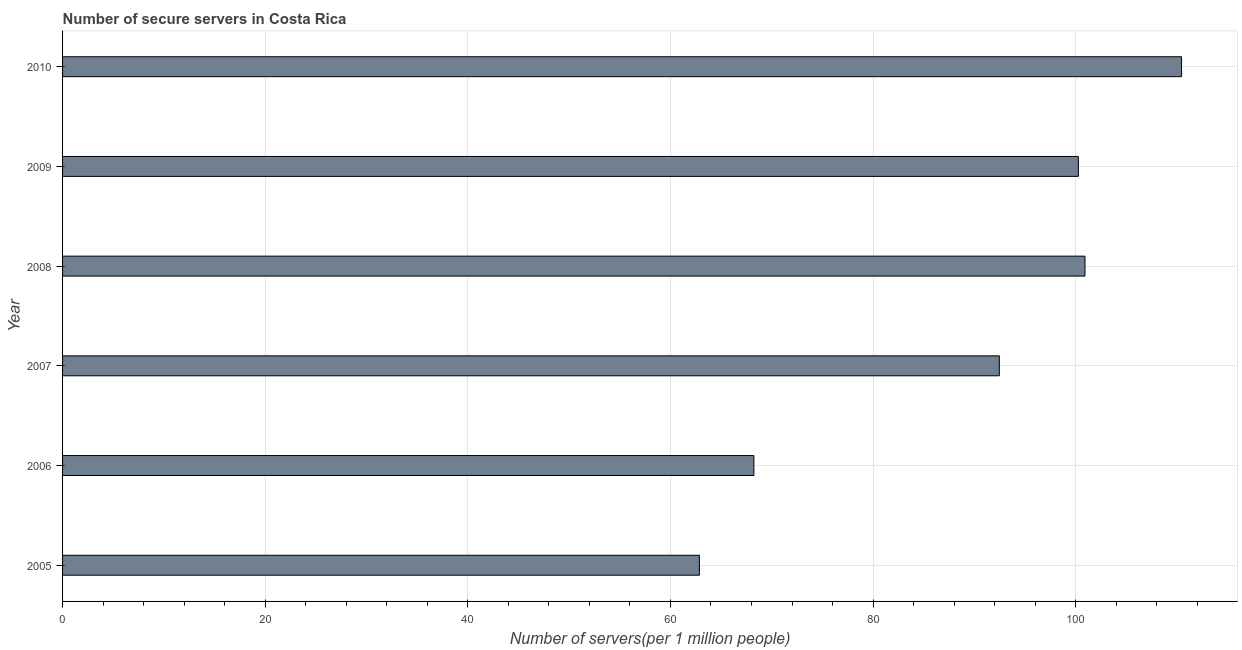Does the graph contain any zero values?
Your answer should be compact. No. Does the graph contain grids?
Your answer should be compact. Yes. What is the title of the graph?
Offer a terse response. Number of secure servers in Costa Rica. What is the label or title of the X-axis?
Give a very brief answer. Number of servers(per 1 million people). What is the label or title of the Y-axis?
Your answer should be very brief. Year. What is the number of secure internet servers in 2010?
Provide a short and direct response. 110.44. Across all years, what is the maximum number of secure internet servers?
Provide a succinct answer. 110.44. Across all years, what is the minimum number of secure internet servers?
Make the answer very short. 62.86. In which year was the number of secure internet servers maximum?
Provide a succinct answer. 2010. What is the sum of the number of secure internet servers?
Offer a terse response. 535.17. What is the difference between the number of secure internet servers in 2007 and 2008?
Offer a very short reply. -8.45. What is the average number of secure internet servers per year?
Keep it short and to the point. 89.19. What is the median number of secure internet servers?
Your answer should be compact. 96.36. In how many years, is the number of secure internet servers greater than 64 ?
Your response must be concise. 5. What is the ratio of the number of secure internet servers in 2005 to that in 2007?
Make the answer very short. 0.68. Is the number of secure internet servers in 2008 less than that in 2010?
Make the answer very short. Yes. What is the difference between the highest and the second highest number of secure internet servers?
Your answer should be very brief. 9.53. What is the difference between the highest and the lowest number of secure internet servers?
Make the answer very short. 47.59. In how many years, is the number of secure internet servers greater than the average number of secure internet servers taken over all years?
Your response must be concise. 4. How many bars are there?
Your answer should be very brief. 6. Are all the bars in the graph horizontal?
Your response must be concise. Yes. How many years are there in the graph?
Give a very brief answer. 6. What is the Number of servers(per 1 million people) in 2005?
Keep it short and to the point. 62.86. What is the Number of servers(per 1 million people) in 2006?
Offer a very short reply. 68.23. What is the Number of servers(per 1 million people) of 2007?
Ensure brevity in your answer.  92.46. What is the Number of servers(per 1 million people) in 2008?
Keep it short and to the point. 100.91. What is the Number of servers(per 1 million people) of 2009?
Give a very brief answer. 100.26. What is the Number of servers(per 1 million people) in 2010?
Ensure brevity in your answer.  110.44. What is the difference between the Number of servers(per 1 million people) in 2005 and 2006?
Offer a terse response. -5.38. What is the difference between the Number of servers(per 1 million people) in 2005 and 2007?
Your answer should be compact. -29.6. What is the difference between the Number of servers(per 1 million people) in 2005 and 2008?
Make the answer very short. -38.06. What is the difference between the Number of servers(per 1 million people) in 2005 and 2009?
Provide a short and direct response. -37.41. What is the difference between the Number of servers(per 1 million people) in 2005 and 2010?
Give a very brief answer. -47.59. What is the difference between the Number of servers(per 1 million people) in 2006 and 2007?
Offer a very short reply. -24.23. What is the difference between the Number of servers(per 1 million people) in 2006 and 2008?
Provide a succinct answer. -32.68. What is the difference between the Number of servers(per 1 million people) in 2006 and 2009?
Make the answer very short. -32.03. What is the difference between the Number of servers(per 1 million people) in 2006 and 2010?
Give a very brief answer. -42.21. What is the difference between the Number of servers(per 1 million people) in 2007 and 2008?
Offer a terse response. -8.45. What is the difference between the Number of servers(per 1 million people) in 2007 and 2009?
Keep it short and to the point. -7.8. What is the difference between the Number of servers(per 1 million people) in 2007 and 2010?
Keep it short and to the point. -17.98. What is the difference between the Number of servers(per 1 million people) in 2008 and 2009?
Your answer should be very brief. 0.65. What is the difference between the Number of servers(per 1 million people) in 2008 and 2010?
Offer a very short reply. -9.53. What is the difference between the Number of servers(per 1 million people) in 2009 and 2010?
Give a very brief answer. -10.18. What is the ratio of the Number of servers(per 1 million people) in 2005 to that in 2006?
Your answer should be very brief. 0.92. What is the ratio of the Number of servers(per 1 million people) in 2005 to that in 2007?
Offer a very short reply. 0.68. What is the ratio of the Number of servers(per 1 million people) in 2005 to that in 2008?
Make the answer very short. 0.62. What is the ratio of the Number of servers(per 1 million people) in 2005 to that in 2009?
Your answer should be very brief. 0.63. What is the ratio of the Number of servers(per 1 million people) in 2005 to that in 2010?
Your answer should be compact. 0.57. What is the ratio of the Number of servers(per 1 million people) in 2006 to that in 2007?
Your response must be concise. 0.74. What is the ratio of the Number of servers(per 1 million people) in 2006 to that in 2008?
Provide a short and direct response. 0.68. What is the ratio of the Number of servers(per 1 million people) in 2006 to that in 2009?
Offer a very short reply. 0.68. What is the ratio of the Number of servers(per 1 million people) in 2006 to that in 2010?
Your answer should be very brief. 0.62. What is the ratio of the Number of servers(per 1 million people) in 2007 to that in 2008?
Make the answer very short. 0.92. What is the ratio of the Number of servers(per 1 million people) in 2007 to that in 2009?
Offer a terse response. 0.92. What is the ratio of the Number of servers(per 1 million people) in 2007 to that in 2010?
Keep it short and to the point. 0.84. What is the ratio of the Number of servers(per 1 million people) in 2008 to that in 2010?
Give a very brief answer. 0.91. What is the ratio of the Number of servers(per 1 million people) in 2009 to that in 2010?
Provide a succinct answer. 0.91. 